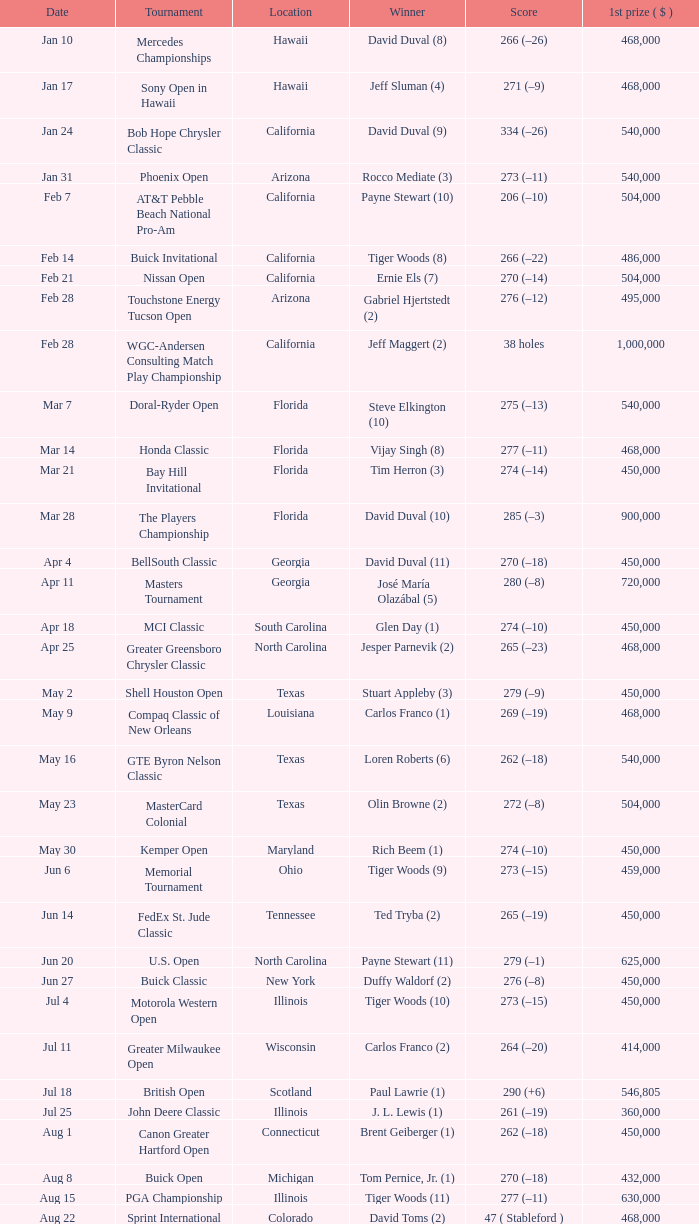What is the score of the B.C. Open in New York? 273 (–15). 